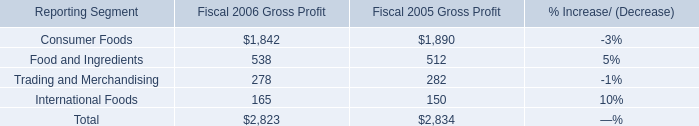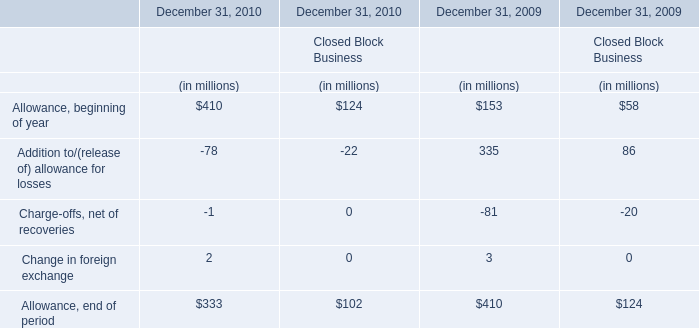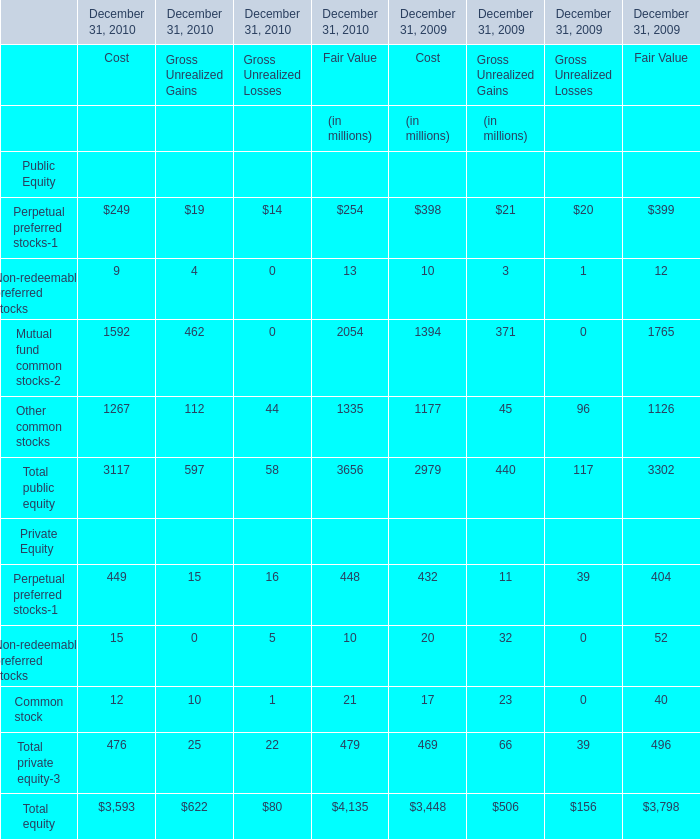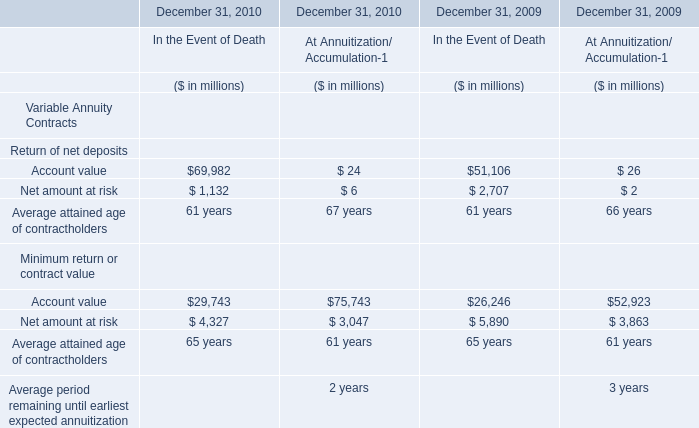What was the total amount of financial services businesses in 2009 ? (in million) 
Computations: (((153 + 335) - 81) + 3)
Answer: 410.0. 